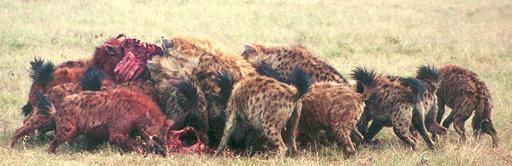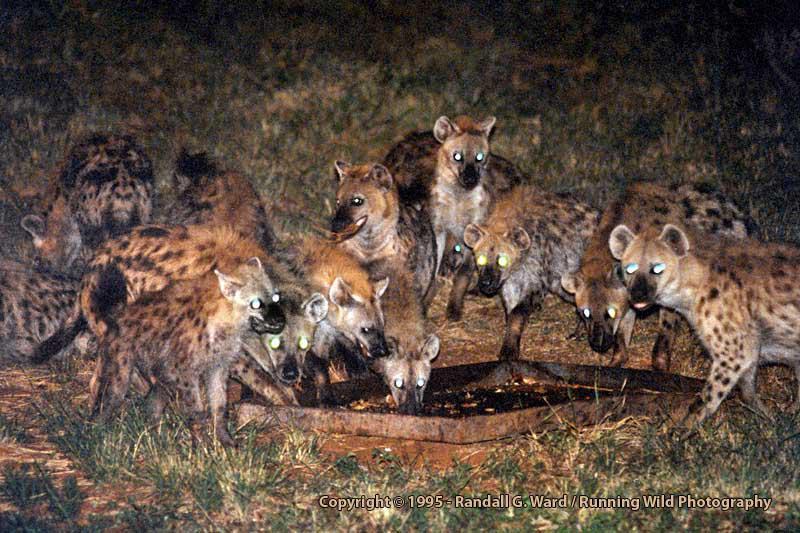The first image is the image on the left, the second image is the image on the right. Assess this claim about the two images: "An image shows a hyena near the carcass of a giraffe with its spotted hooved legs visible.". Correct or not? Answer yes or no. No. The first image is the image on the left, the second image is the image on the right. Considering the images on both sides, is "One of the images features only one hyena." valid? Answer yes or no. No. 